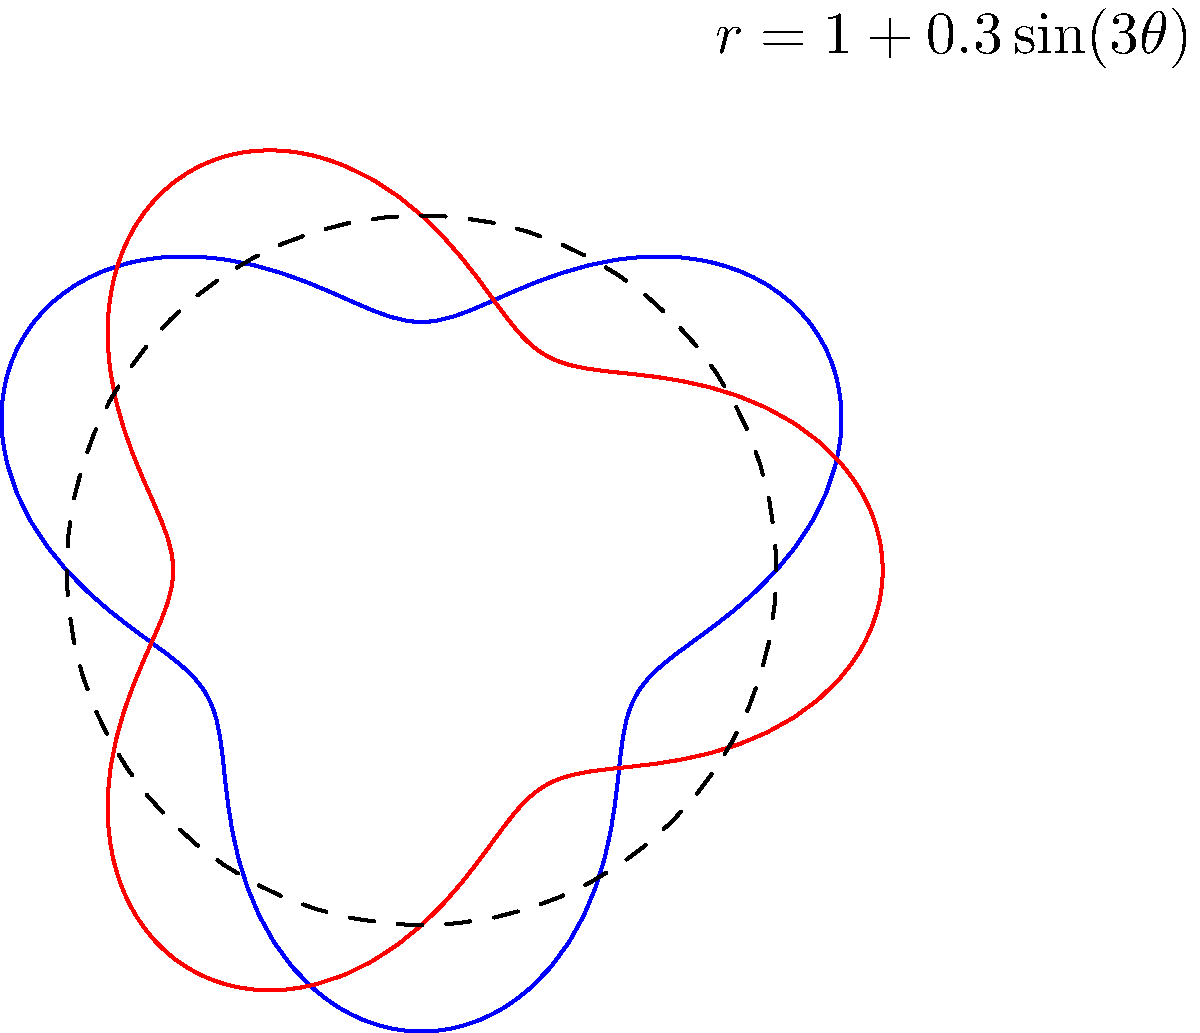You're designing a new interlocking ring set for your jewelry line. The base shape for each ring is given by the polar equation $r = 1 + 0.3\sin(3\theta)$. To create the interlocking effect, you rotate one ring by 90 degrees relative to the other. What is the maximum number of intersection points between the two rings? To solve this problem, let's follow these steps:

1) First, note that the equation $r = 1 + 0.3\sin(3\theta)$ creates a flower-like shape with 3 "petals" due to the $\sin(3\theta)$ term.

2) The base shape (blue in the diagram) intersects the unit circle (dashed) at 6 points. This is because $\sin(3\theta)$ completes 3 full cycles as $\theta$ goes from 0 to $2\pi$.

3) When we rotate this shape by 90 degrees (red in the diagram), it creates a similar pattern but rotated.

4) The maximum number of intersections will occur when the "peaks" of one shape align with the "valleys" of the other.

5) Given that each shape has 3 peaks and 3 valleys, and they're rotated relative to each other, they will intersect at:
   - 6 points where they cross the unit circle
   - 6 additional points between these crossings

6) Therefore, the maximum total number of intersection points is 12.

This interlocking design creates a visually intricate piece that showcases the mathematical precision in your jewelry crafting.
Answer: 12 intersection points 